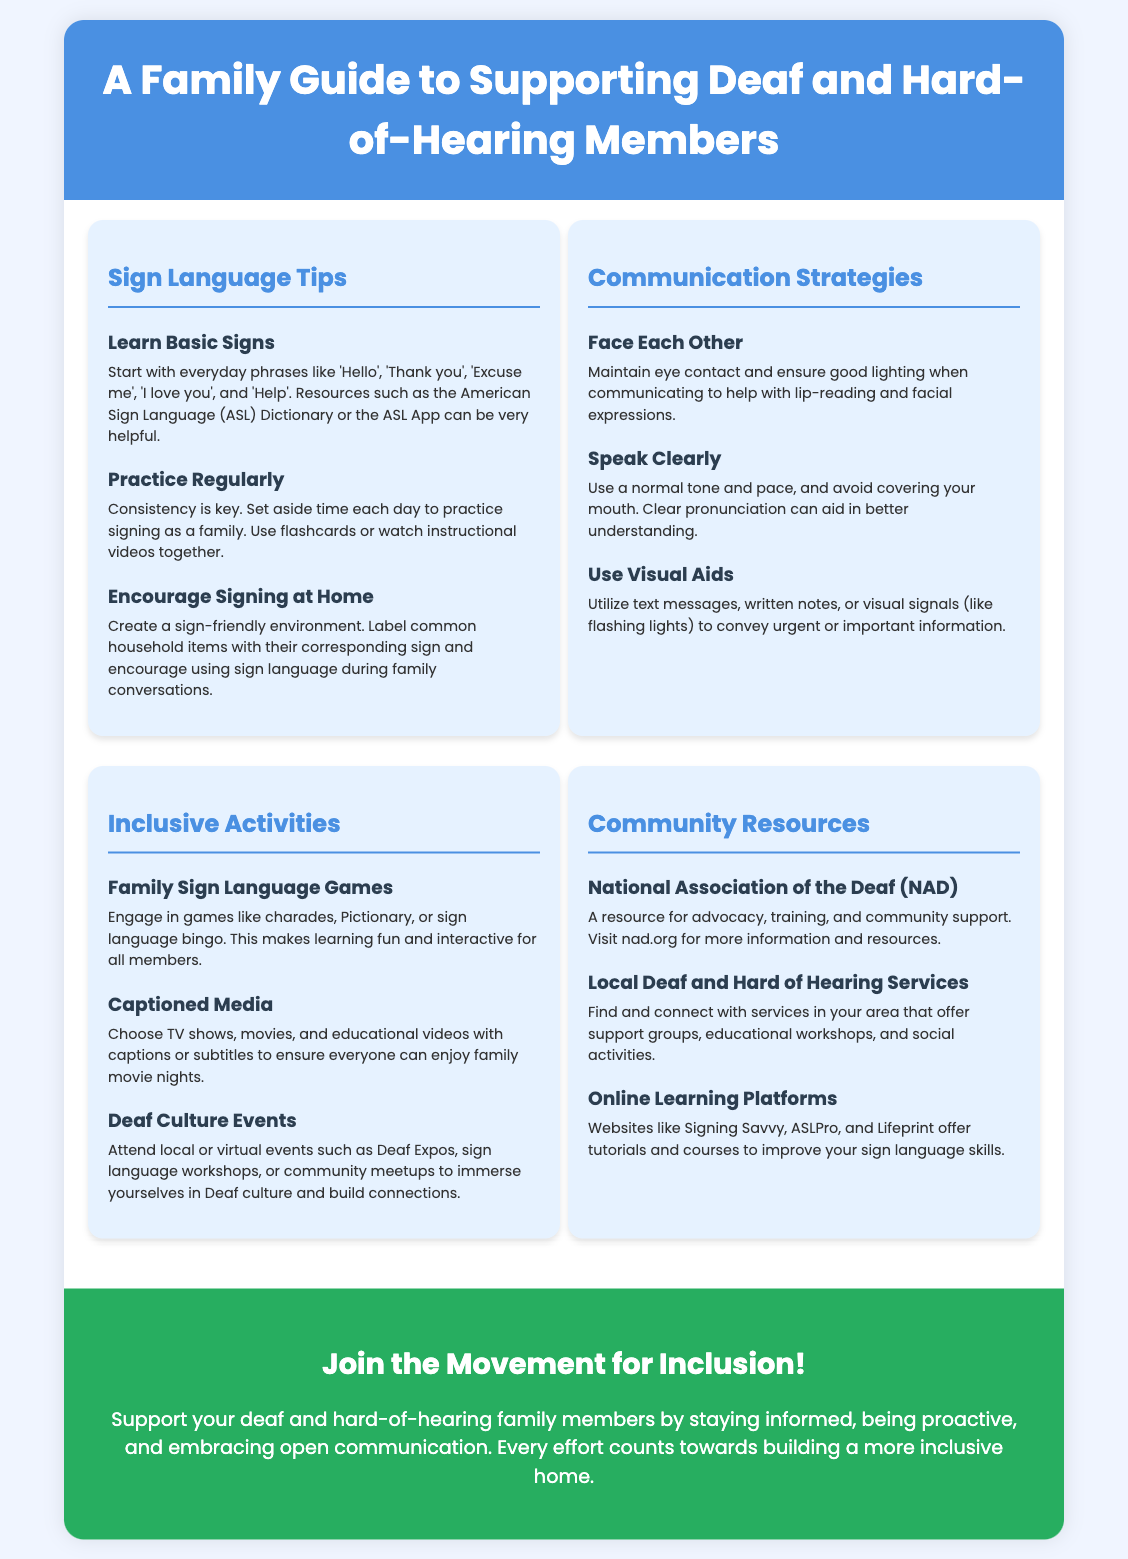What is the title of the poster? The title is prominently displayed at the top of the poster, offering a clear understanding of its purpose.
Answer: A Family Guide to Supporting Deaf and Hard-of-Hearing Members What organization's website can be visited for more resources? The poster mentions a specific organization related to Deaf advocacy that provides additional resources.
Answer: nad.org What should families do to encourage signing at home? One of the tips emphasizes creating an environment that fosters the use of sign language among family members.
Answer: Label common household items What is one of the recommended family sign language games? The document lists interactive activities that can help family members learn sign language while having fun.
Answer: Sign language bingo How many sections are there in the content area? The document contains a specific number of sections dedicated to various supportive strategies and resources.
Answer: Four 